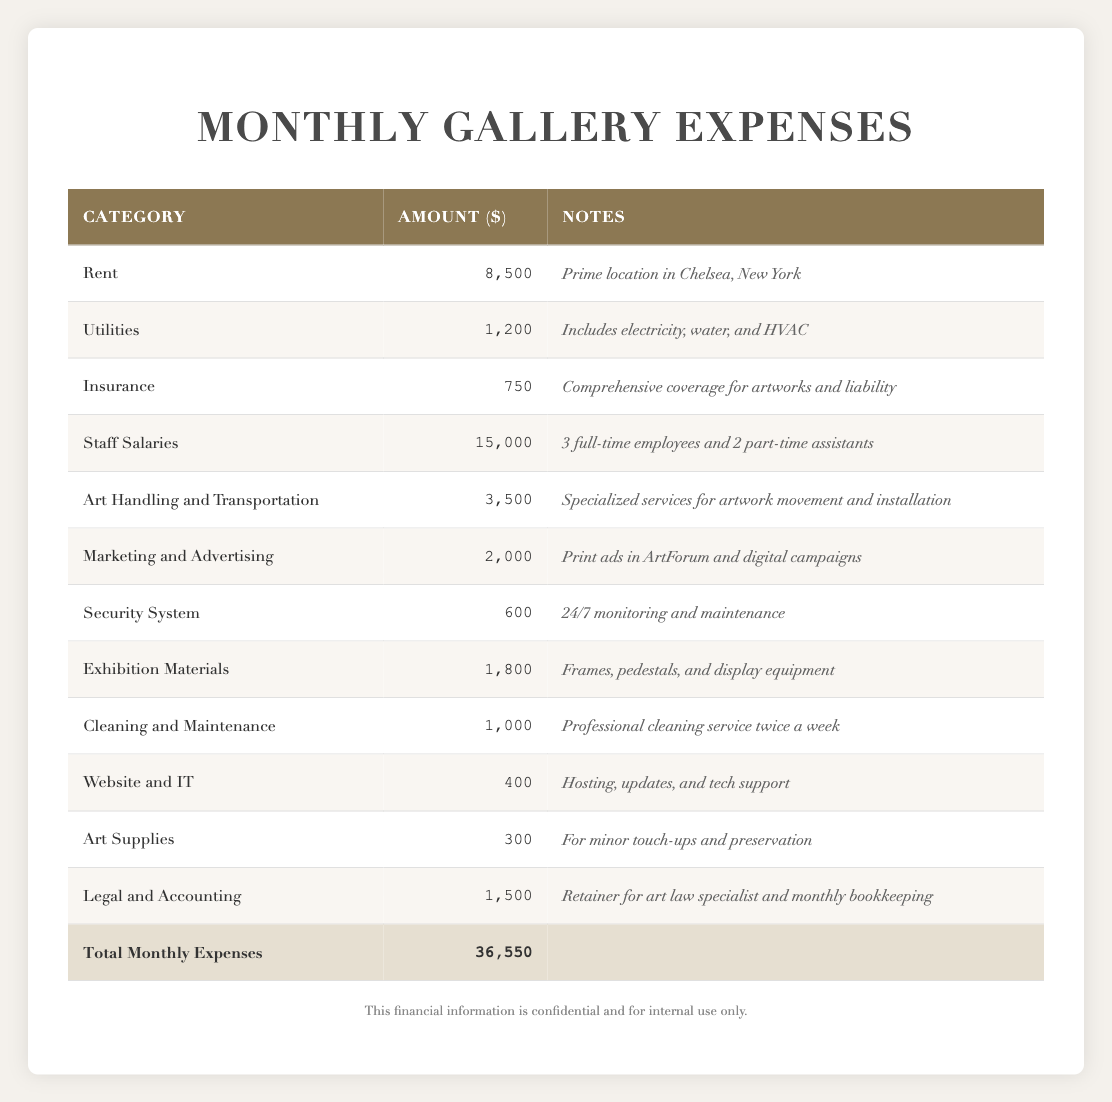What is the total amount spent on staff salaries? The table shows the category "Staff Salaries" with an amount of 15,000, so the total spent on this category is directly listed under it.
Answer: 15,000 What are the monthly expenses for utilities? The category "Utilities" lists an amount of 1,200, which is the monthly expense for that category.
Answer: 1,200 Is the gallery's total monthly expense greater than 30,000? To check this, we look at the total expenses listed at the end of the table, which is 36,550. Since 36,550 is greater than 30,000, the answer is yes.
Answer: Yes What is the amount spent on marketing and advertising, and how does it compare to security system expenses? The table shows "Marketing and Advertising" amounts to 2,000 and "Security System" amounts to 600. Therefore, marketing expenses are substantially higher, specifically by 2,000 - 600 = 1,400.
Answer: 2,000 (higher by 1,400) What percentage of the total monthly expenses is allocated to rent? The total monthly expenses are 36,550, and rent is 8,500. To find the percentage, we calculate (8,500 / 36,550) * 100, which approximates to 23.26%.
Answer: 23.26% 